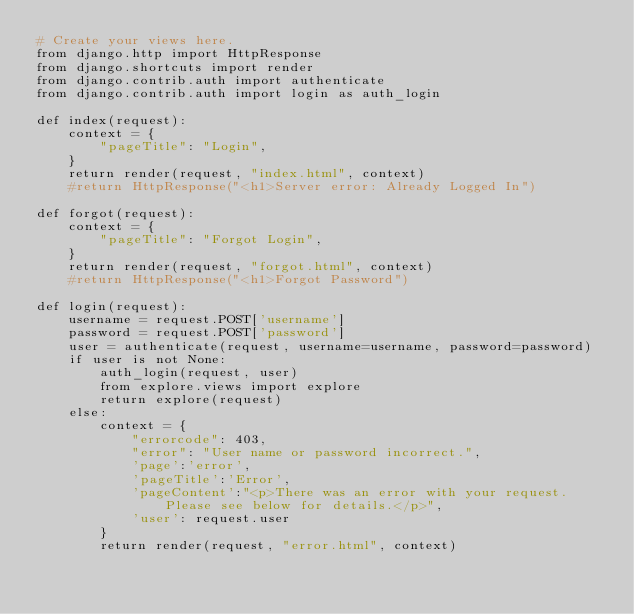Convert code to text. <code><loc_0><loc_0><loc_500><loc_500><_Python_># Create your views here.
from django.http import HttpResponse
from django.shortcuts import render
from django.contrib.auth import authenticate
from django.contrib.auth import login as auth_login

def index(request):
    context = {
        "pageTitle": "Login",
    }
    return render(request, "index.html", context)
    #return HttpResponse("<h1>Server error: Already Logged In")

def forgot(request):
    context = {
        "pageTitle": "Forgot Login",
    }
    return render(request, "forgot.html", context)
    #return HttpResponse("<h1>Forgot Password")

def login(request):
    username = request.POST['username']
    password = request.POST['password']
    user = authenticate(request, username=username, password=password)
    if user is not None:
        auth_login(request, user)
        from explore.views import explore
        return explore(request)
    else:
        context = {
            "errorcode": 403,
            "error": "User name or password incorrect.",
            'page':'error',
            'pageTitle':'Error',
            'pageContent':"<p>There was an error with your request. Please see below for details.</p>",
            'user': request.user
        }
        return render(request, "error.html", context)
</code> 